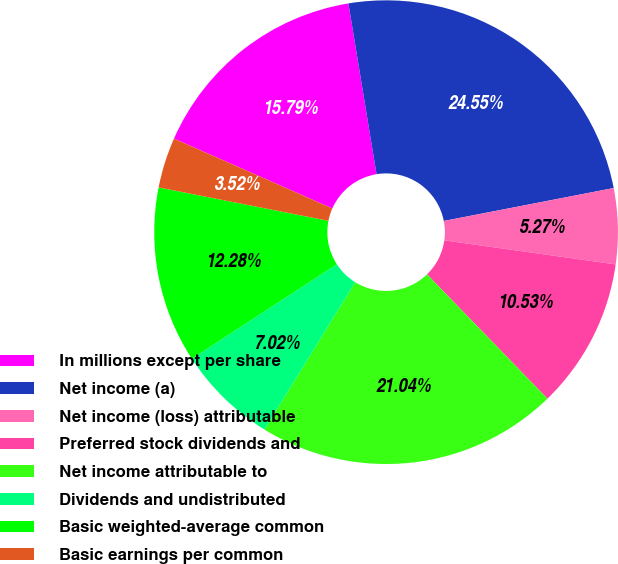Convert chart to OTSL. <chart><loc_0><loc_0><loc_500><loc_500><pie_chart><fcel>In millions except per share<fcel>Net income (a)<fcel>Net income (loss) attributable<fcel>Preferred stock dividends and<fcel>Net income attributable to<fcel>Dividends and undistributed<fcel>Basic weighted-average common<fcel>Basic earnings per common<nl><fcel>15.79%<fcel>24.55%<fcel>5.27%<fcel>10.53%<fcel>21.04%<fcel>7.02%<fcel>12.28%<fcel>3.52%<nl></chart> 